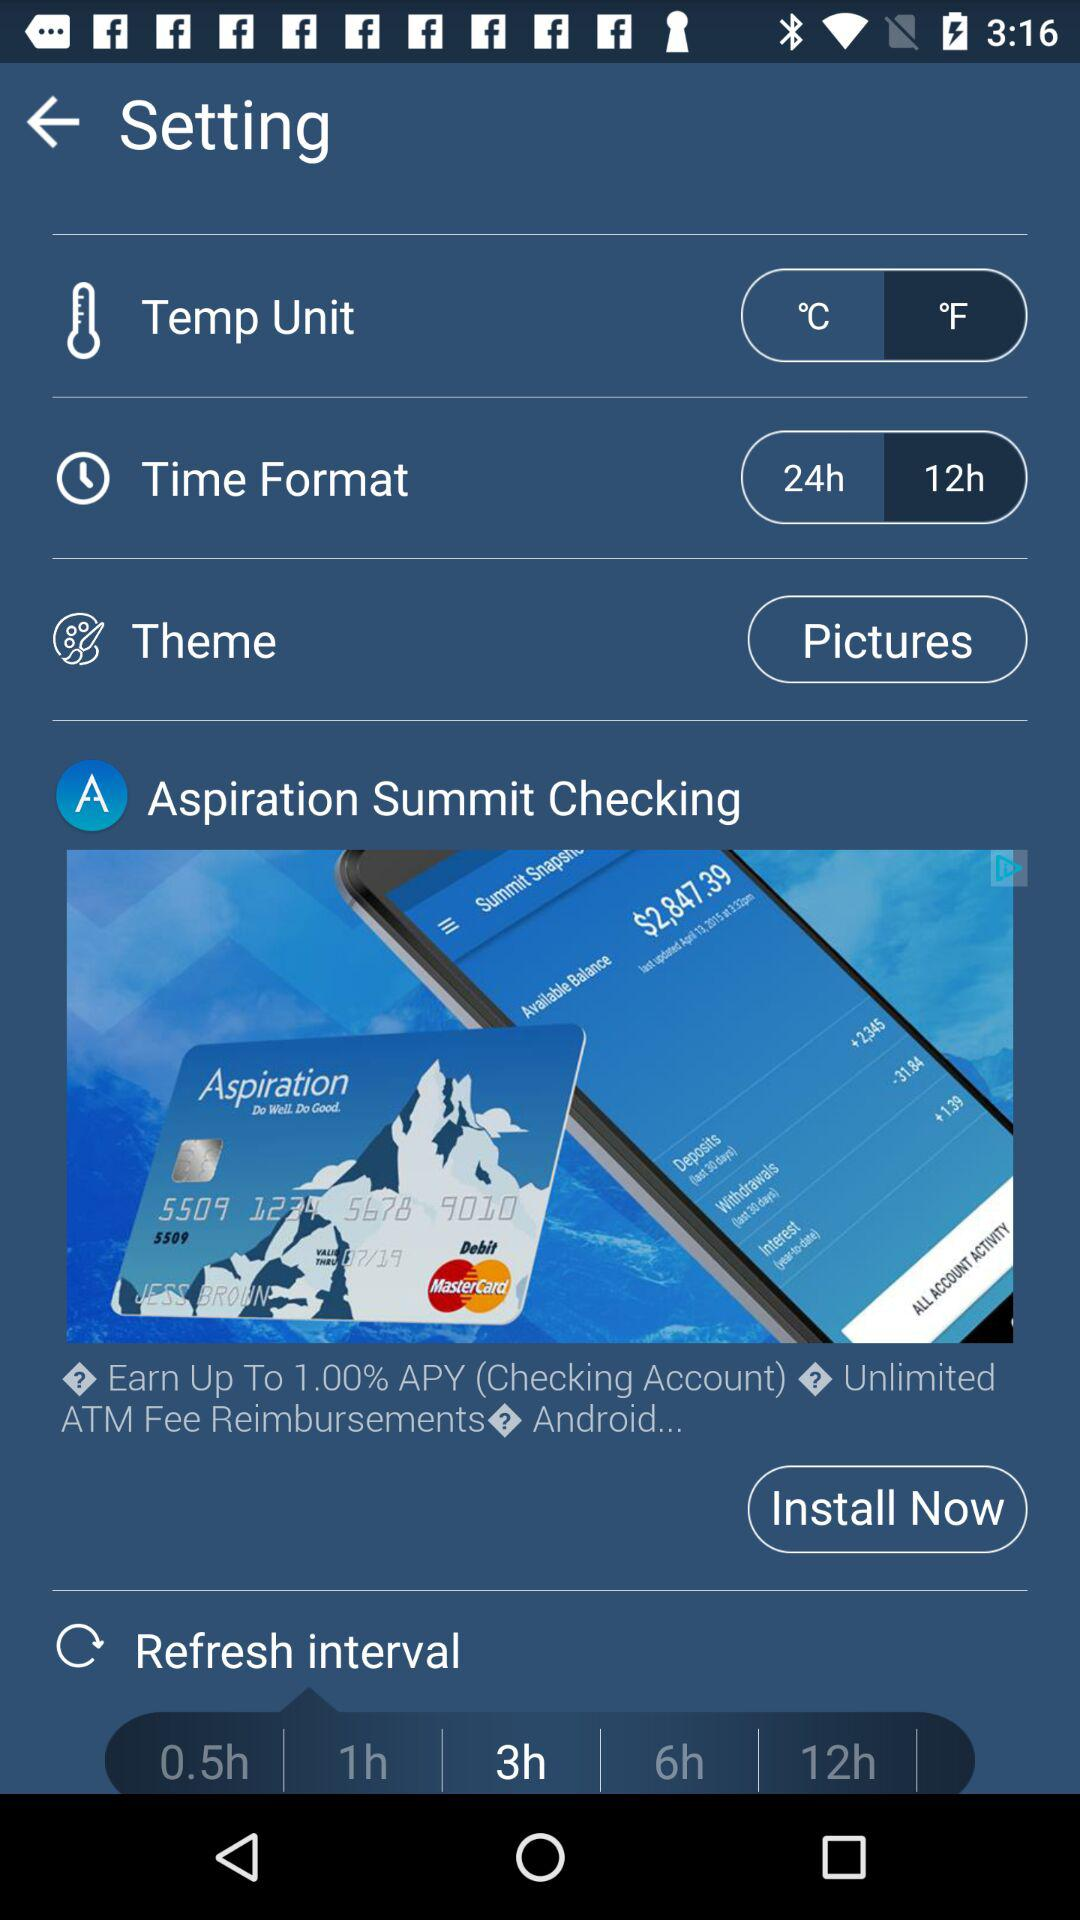What is the theme? The theme is "Pictures". 